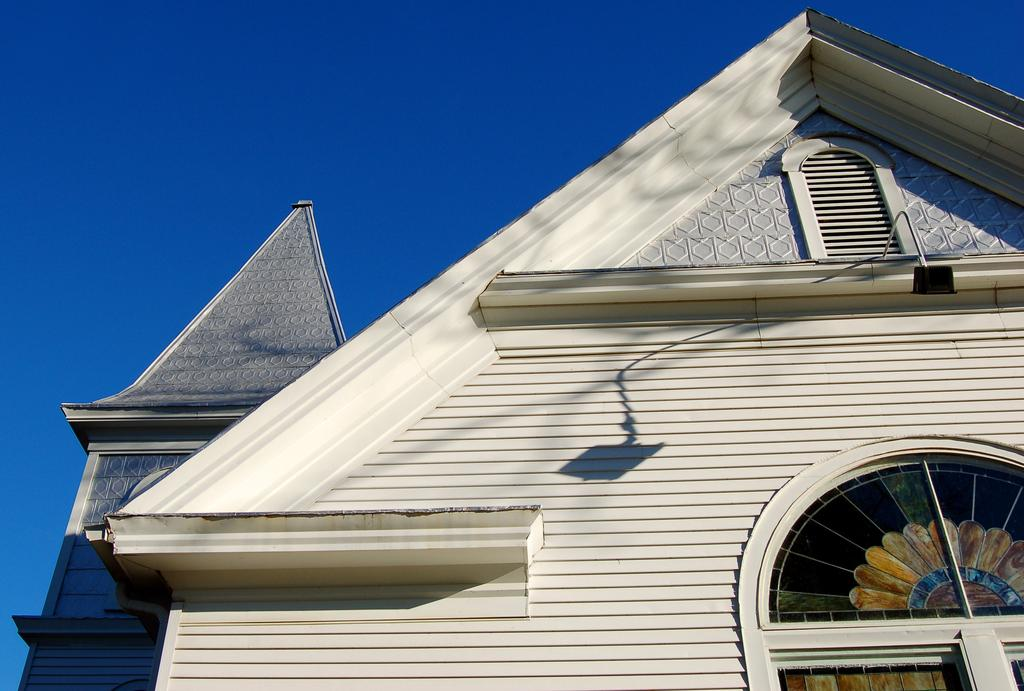What type of structure is present in the image? There is a small white color wooden shed house in the image. Can you describe the door of the shed house? The shed house has a colorful door glass. What type of boundary is visible around the shed house in the image? There is no boundary visible around the shed house in the image. Can you describe the whip used by the person inside the shed house in the image? There is no person or whip present in the image. 